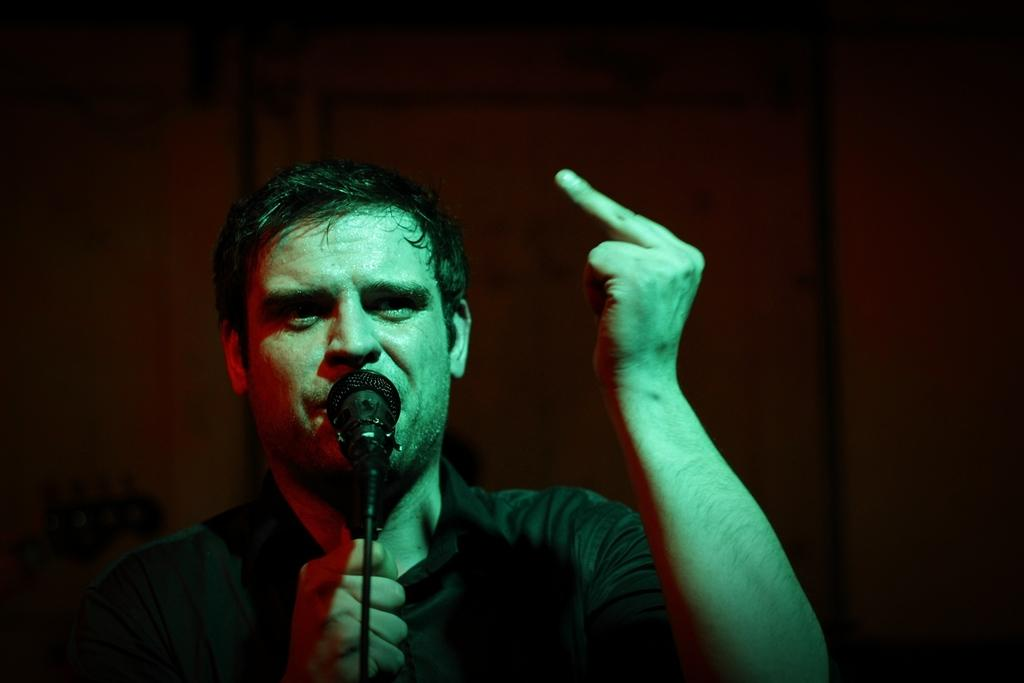What is the main subject in the foreground of the image? There is a person in the foreground of the image. What is the person doing in the image? The person is talking. What object is in front of the person? There is a microphone in front of the person. Can you describe the background of the image? The background of the image is blurred. Can you see any fangs on the person in the image? There are no fangs visible on the person in the image. What type of camp is set up in the background of the image? There is no camp present in the image; the background is blurred. 